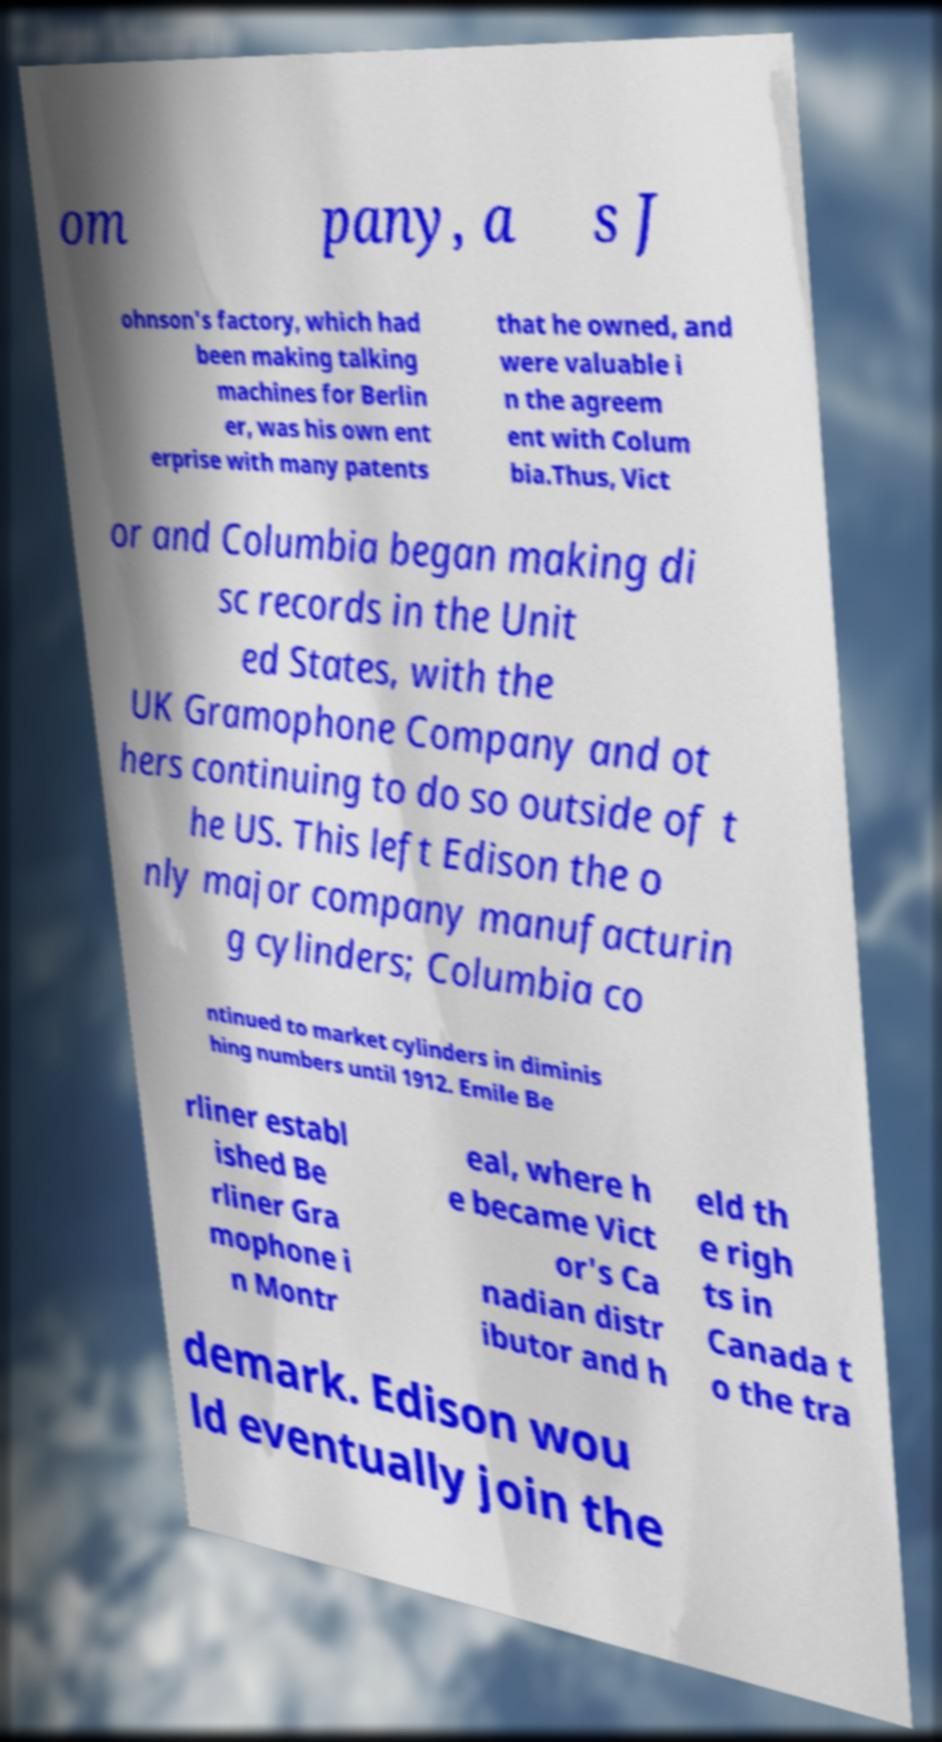Please identify and transcribe the text found in this image. om pany, a s J ohnson's factory, which had been making talking machines for Berlin er, was his own ent erprise with many patents that he owned, and were valuable i n the agreem ent with Colum bia.Thus, Vict or and Columbia began making di sc records in the Unit ed States, with the UK Gramophone Company and ot hers continuing to do so outside of t he US. This left Edison the o nly major company manufacturin g cylinders; Columbia co ntinued to market cylinders in diminis hing numbers until 1912. Emile Be rliner establ ished Be rliner Gra mophone i n Montr eal, where h e became Vict or's Ca nadian distr ibutor and h eld th e righ ts in Canada t o the tra demark. Edison wou ld eventually join the 